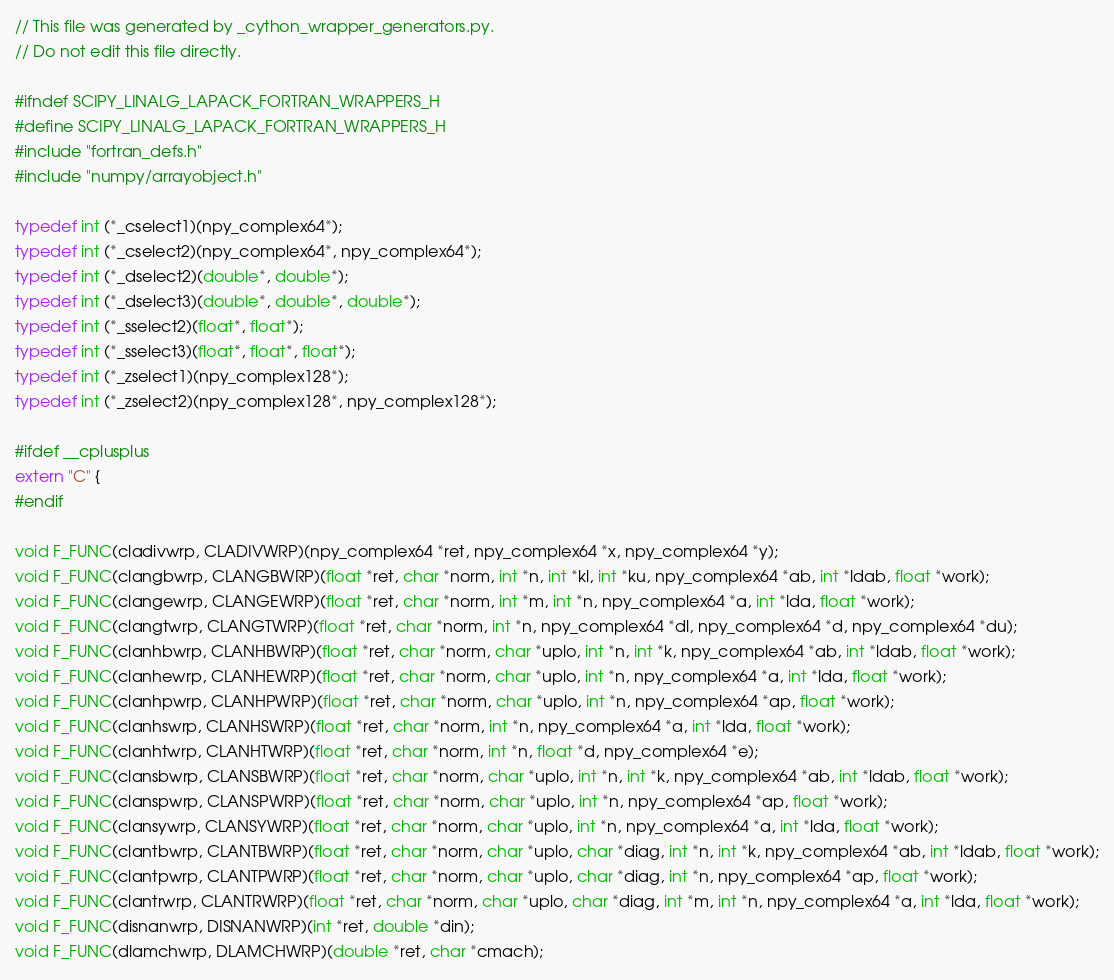Convert code to text. <code><loc_0><loc_0><loc_500><loc_500><_C_>// This file was generated by _cython_wrapper_generators.py.
// Do not edit this file directly.

#ifndef SCIPY_LINALG_LAPACK_FORTRAN_WRAPPERS_H
#define SCIPY_LINALG_LAPACK_FORTRAN_WRAPPERS_H
#include "fortran_defs.h"
#include "numpy/arrayobject.h"

typedef int (*_cselect1)(npy_complex64*);
typedef int (*_cselect2)(npy_complex64*, npy_complex64*);
typedef int (*_dselect2)(double*, double*);
typedef int (*_dselect3)(double*, double*, double*);
typedef int (*_sselect2)(float*, float*);
typedef int (*_sselect3)(float*, float*, float*);
typedef int (*_zselect1)(npy_complex128*);
typedef int (*_zselect2)(npy_complex128*, npy_complex128*);

#ifdef __cplusplus
extern "C" {
#endif

void F_FUNC(cladivwrp, CLADIVWRP)(npy_complex64 *ret, npy_complex64 *x, npy_complex64 *y);
void F_FUNC(clangbwrp, CLANGBWRP)(float *ret, char *norm, int *n, int *kl, int *ku, npy_complex64 *ab, int *ldab, float *work);
void F_FUNC(clangewrp, CLANGEWRP)(float *ret, char *norm, int *m, int *n, npy_complex64 *a, int *lda, float *work);
void F_FUNC(clangtwrp, CLANGTWRP)(float *ret, char *norm, int *n, npy_complex64 *dl, npy_complex64 *d, npy_complex64 *du);
void F_FUNC(clanhbwrp, CLANHBWRP)(float *ret, char *norm, char *uplo, int *n, int *k, npy_complex64 *ab, int *ldab, float *work);
void F_FUNC(clanhewrp, CLANHEWRP)(float *ret, char *norm, char *uplo, int *n, npy_complex64 *a, int *lda, float *work);
void F_FUNC(clanhpwrp, CLANHPWRP)(float *ret, char *norm, char *uplo, int *n, npy_complex64 *ap, float *work);
void F_FUNC(clanhswrp, CLANHSWRP)(float *ret, char *norm, int *n, npy_complex64 *a, int *lda, float *work);
void F_FUNC(clanhtwrp, CLANHTWRP)(float *ret, char *norm, int *n, float *d, npy_complex64 *e);
void F_FUNC(clansbwrp, CLANSBWRP)(float *ret, char *norm, char *uplo, int *n, int *k, npy_complex64 *ab, int *ldab, float *work);
void F_FUNC(clanspwrp, CLANSPWRP)(float *ret, char *norm, char *uplo, int *n, npy_complex64 *ap, float *work);
void F_FUNC(clansywrp, CLANSYWRP)(float *ret, char *norm, char *uplo, int *n, npy_complex64 *a, int *lda, float *work);
void F_FUNC(clantbwrp, CLANTBWRP)(float *ret, char *norm, char *uplo, char *diag, int *n, int *k, npy_complex64 *ab, int *ldab, float *work);
void F_FUNC(clantpwrp, CLANTPWRP)(float *ret, char *norm, char *uplo, char *diag, int *n, npy_complex64 *ap, float *work);
void F_FUNC(clantrwrp, CLANTRWRP)(float *ret, char *norm, char *uplo, char *diag, int *m, int *n, npy_complex64 *a, int *lda, float *work);
void F_FUNC(disnanwrp, DISNANWRP)(int *ret, double *din);
void F_FUNC(dlamchwrp, DLAMCHWRP)(double *ret, char *cmach);</code> 